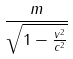Convert formula to latex. <formula><loc_0><loc_0><loc_500><loc_500>\frac { m } { \sqrt { 1 - \frac { v ^ { 2 } } { c ^ { 2 } } } }</formula> 